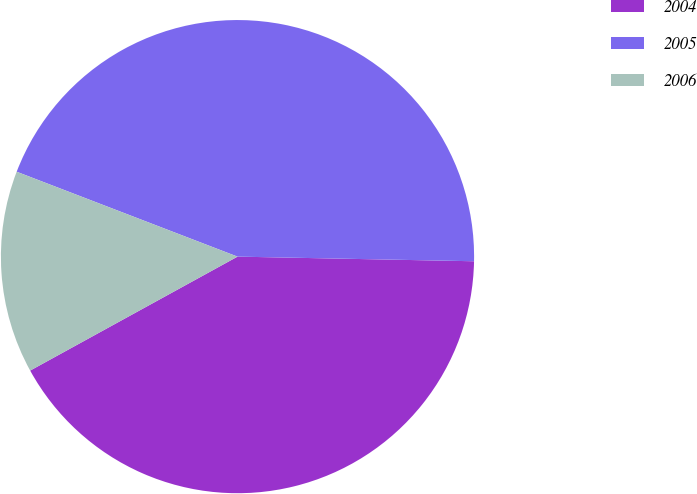<chart> <loc_0><loc_0><loc_500><loc_500><pie_chart><fcel>2004<fcel>2005<fcel>2006<nl><fcel>41.69%<fcel>44.47%<fcel>13.84%<nl></chart> 